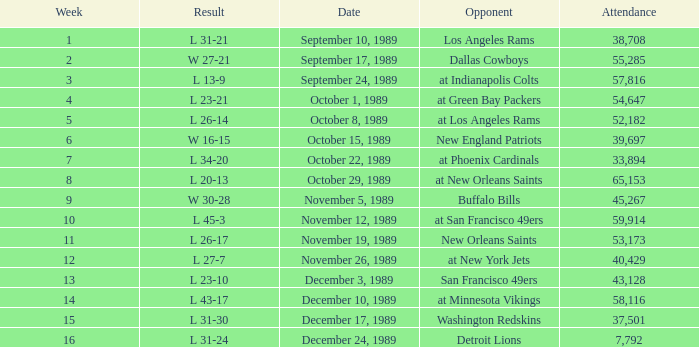For what week was the attendance 40,429? 12.0. 